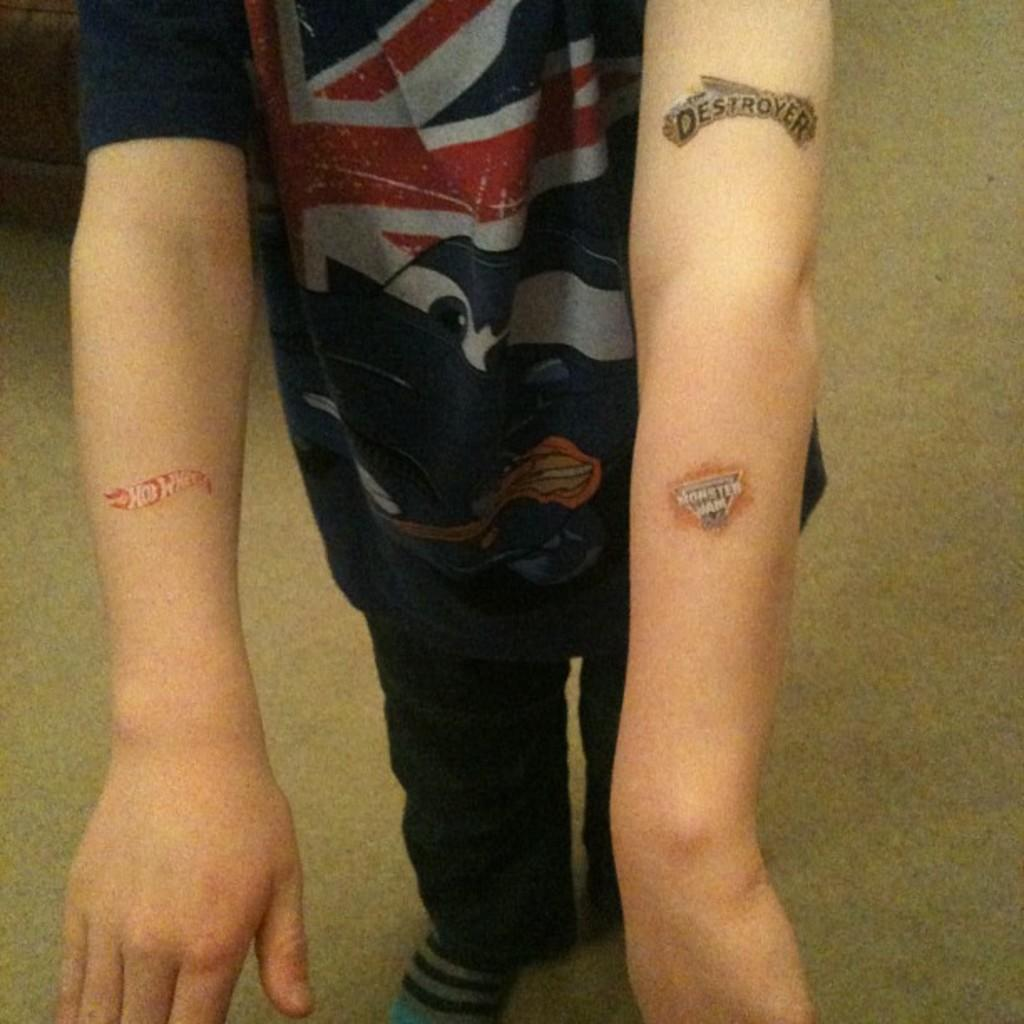<image>
Write a terse but informative summary of the picture. a boy with fake tattoos that say HOT WHEELS, DESTROYER and MONSTER JAM. 